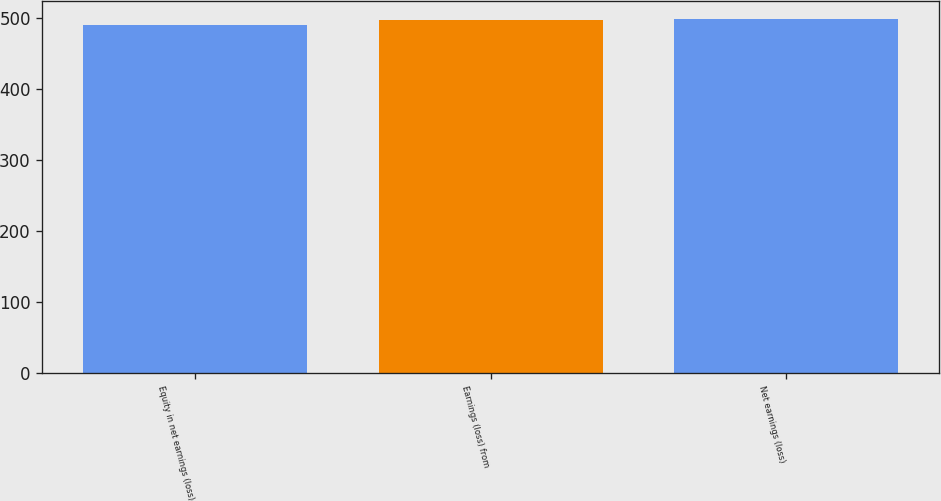Convert chart. <chart><loc_0><loc_0><loc_500><loc_500><bar_chart><fcel>Equity in net earnings (loss)<fcel>Earnings (loss) from<fcel>Net earnings (loss)<nl><fcel>491<fcel>498<fcel>499.4<nl></chart> 